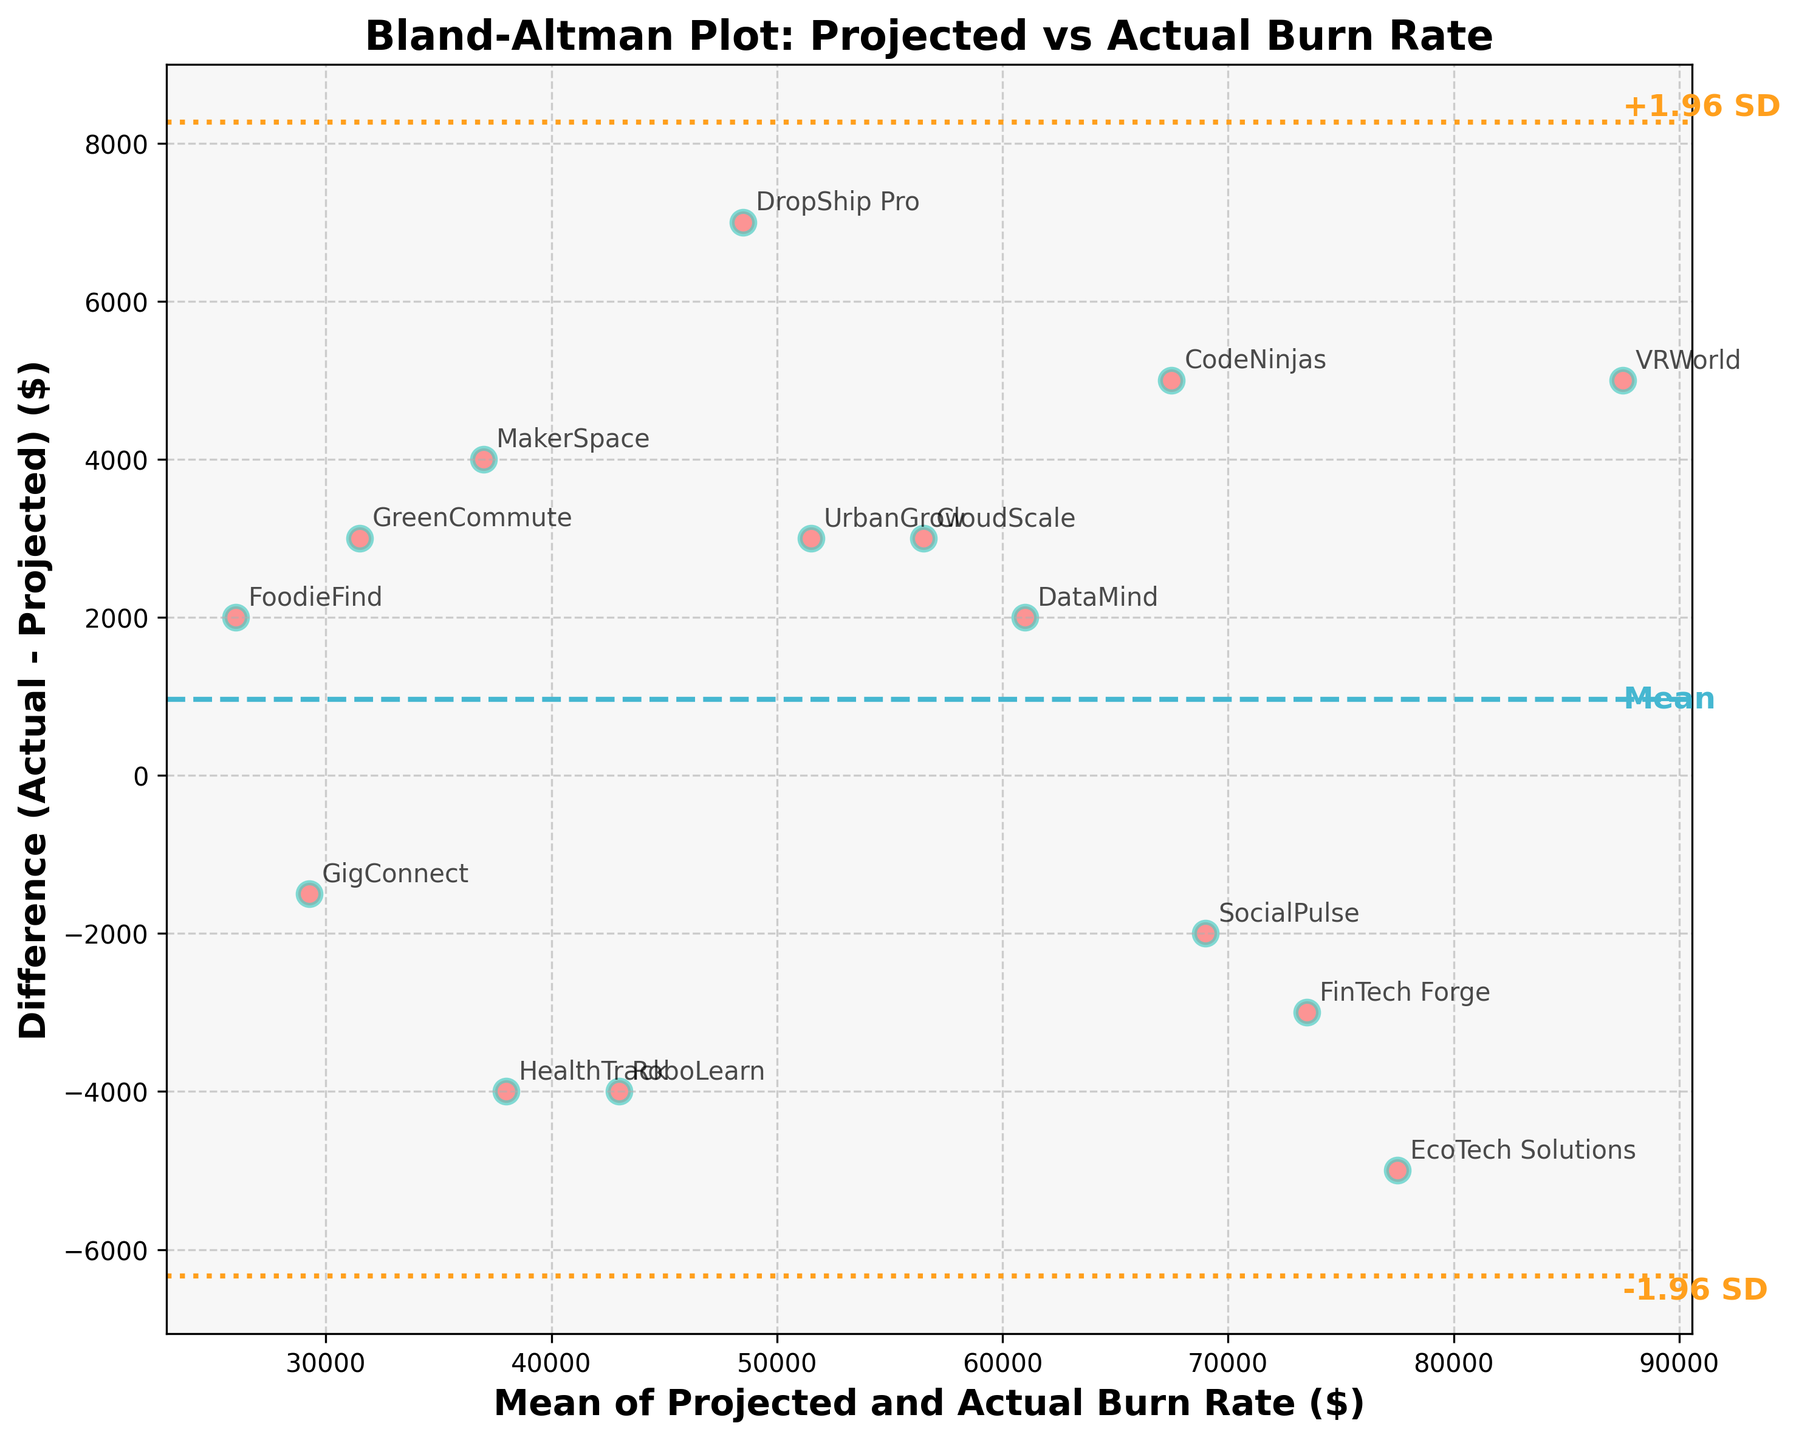What is the title of the plot? The title is typically written at the top of the plot and serves to describe what the plot represents. Here, the title "Bland-Altman Plot: Projected vs Actual Burn Rate" is clearly visible.
Answer: Bland-Altman Plot: Projected vs Actual Burn Rate What are the axes labeled as? Axes labels describe what the axes represent. The x-axis is labeled "Mean of Projected and Actual Burn Rate ($)" and the y-axis is labeled "Difference (Actual - Projected) ($)".
Answer: Mean of Projected and Actual Burn Rate ($) and Difference (Actual - Projected) ($) How many data points are in the plot? Each data point corresponds to a startup labeled by its name, and there are 15 startups listed in the data. Thus, there are 15 data points in the plot.
Answer: 15 Which startup has the highest positive difference between actual and projected burn rate? By looking at the vertical position of the points, the highest point represents the largest positive difference. According to the plot, "VRWorld" is at the highest positive position.
Answer: VRWorld What is the color of the dashed line representing the mean difference? The mean difference line is represented by a dashed line, and its color is blue.
Answer: Blue Does any startup have an actual burn rate lower than its projected burn rate? To find this, look for points below the y=0 line, which indicates a negative difference. "HealthTrack" and "RoboLearn" are examples of startups with actual burn rates lower than their projected rates.
Answer: Yes What are the values of the mean and the ±1.96 standard deviations lines? First, locate the horizontal dashed line for the mean and the dotted lines for ±1.96 SD. The mean difference is at 0 and the ±1.96 SD limits (lines) are approximately at +14,000 and -14,000.
Answer: 0, +14,000, -14,000 Which startup has its mean burn rate closest to 50,000 dollars? Look on the x-axis for a mean value around 50,000. The startup "UrbanGrow" is the closest to this mean value.
Answer: UrbanGrow Is there a larger spread in differences at higher mean burn rates compared to lower mean burn rates? To determine this, observe the range of differences (y-values) for higher mean burn rates (right side of the plot) versus lower mean burn rates (left side of the plot). Higher mean burn rates tend to show a wider spread in differences.
Answer: Yes What can you infer about the accuracy of the burn rate projections for lower burn rate startups compared to higher burn rate startups? Check the consistency of points around the mean difference line at different burn rate levels. Lower burn rate startups (left side of the plot) appear to cluster closer to the mean difference line, indicating more accurate projections than higher burn rate startups (right side).
Answer: Projections are more accurate for lower burn rate startups 